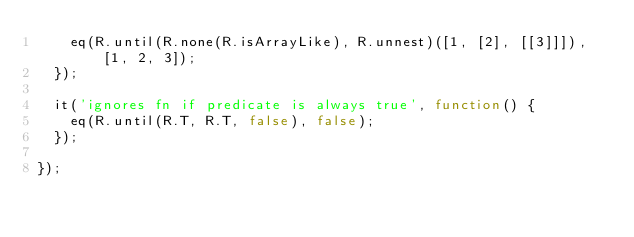Convert code to text. <code><loc_0><loc_0><loc_500><loc_500><_JavaScript_>    eq(R.until(R.none(R.isArrayLike), R.unnest)([1, [2], [[3]]]), [1, 2, 3]);
  });

  it('ignores fn if predicate is always true', function() {
    eq(R.until(R.T, R.T, false), false);
  });

});
</code> 